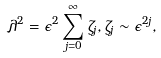Convert formula to latex. <formula><loc_0><loc_0><loc_500><loc_500>\lambda ^ { 2 } = \epsilon ^ { 2 } \sum _ { j = 0 } ^ { \infty } \zeta _ { j } , \zeta _ { j } \sim \epsilon ^ { 2 j } ,</formula> 